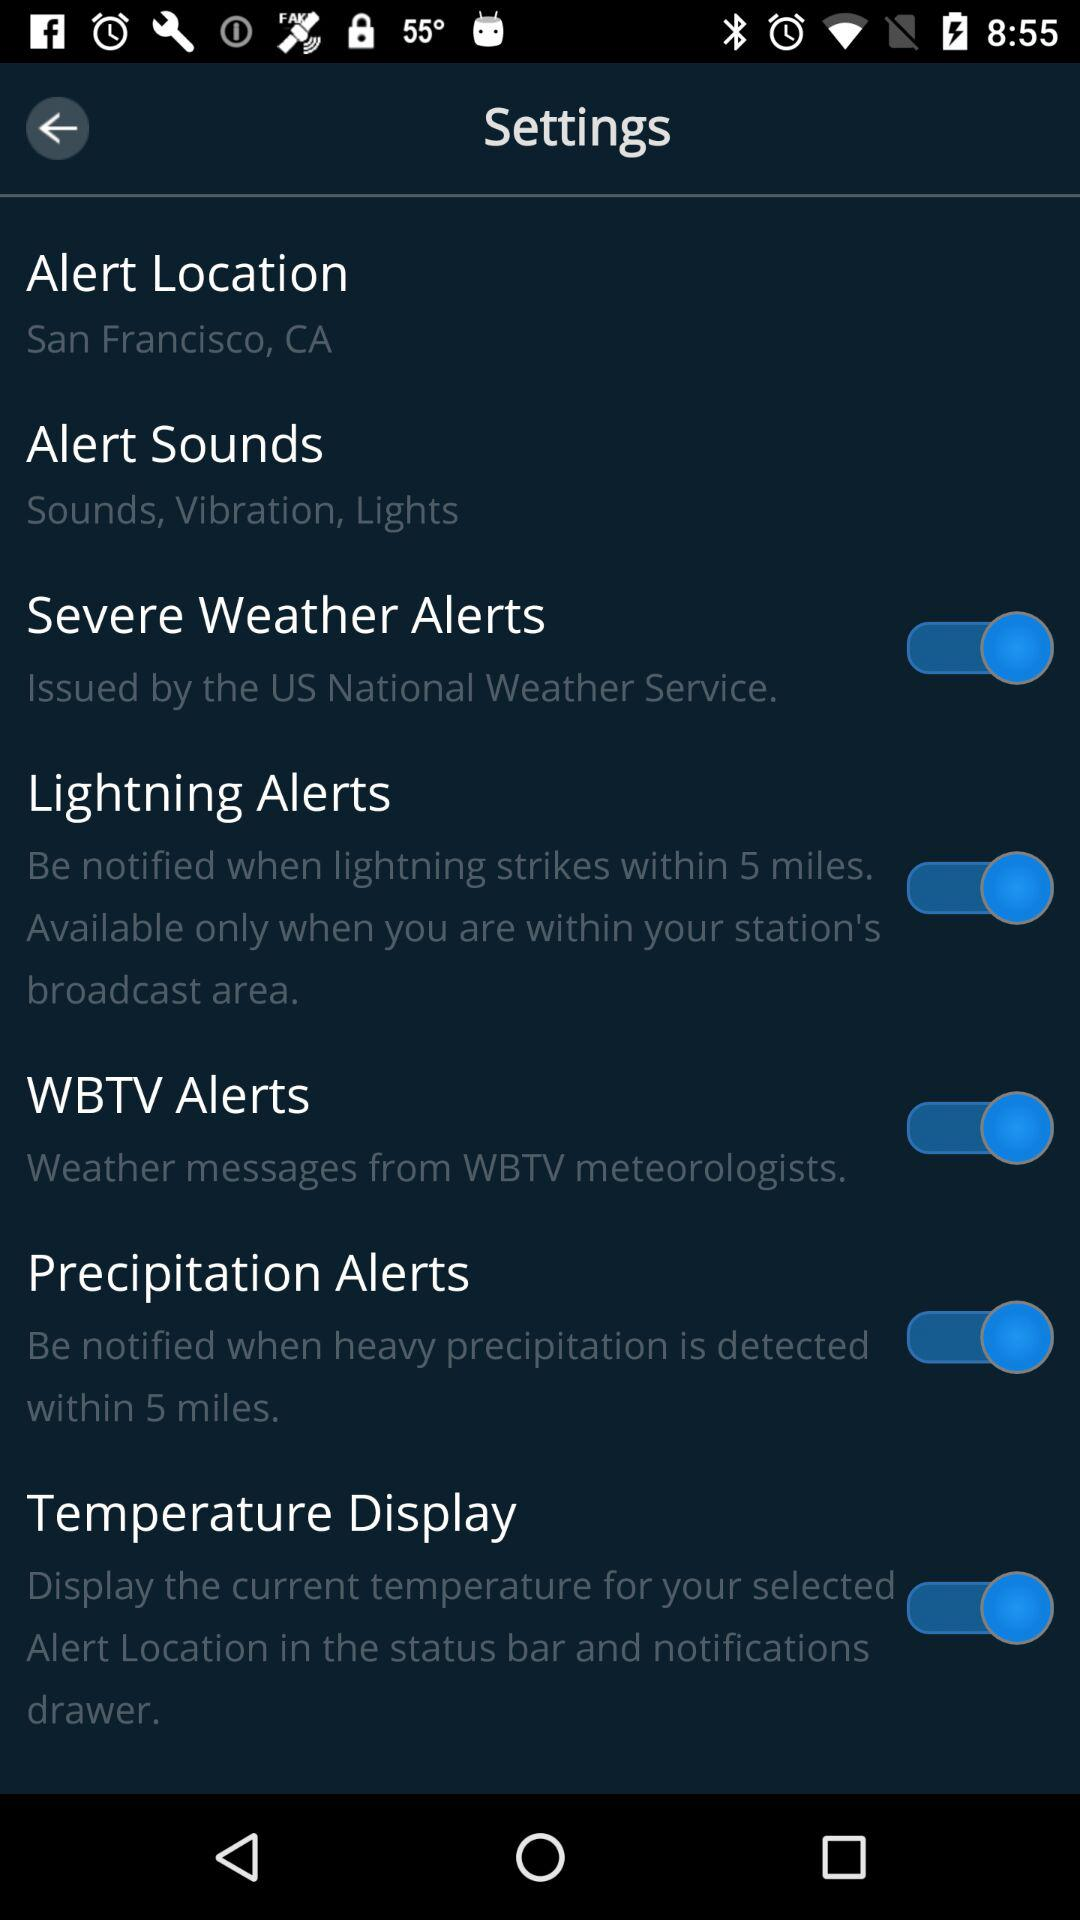What is the status of "Severe Weather Alerts"? The status is "on". 